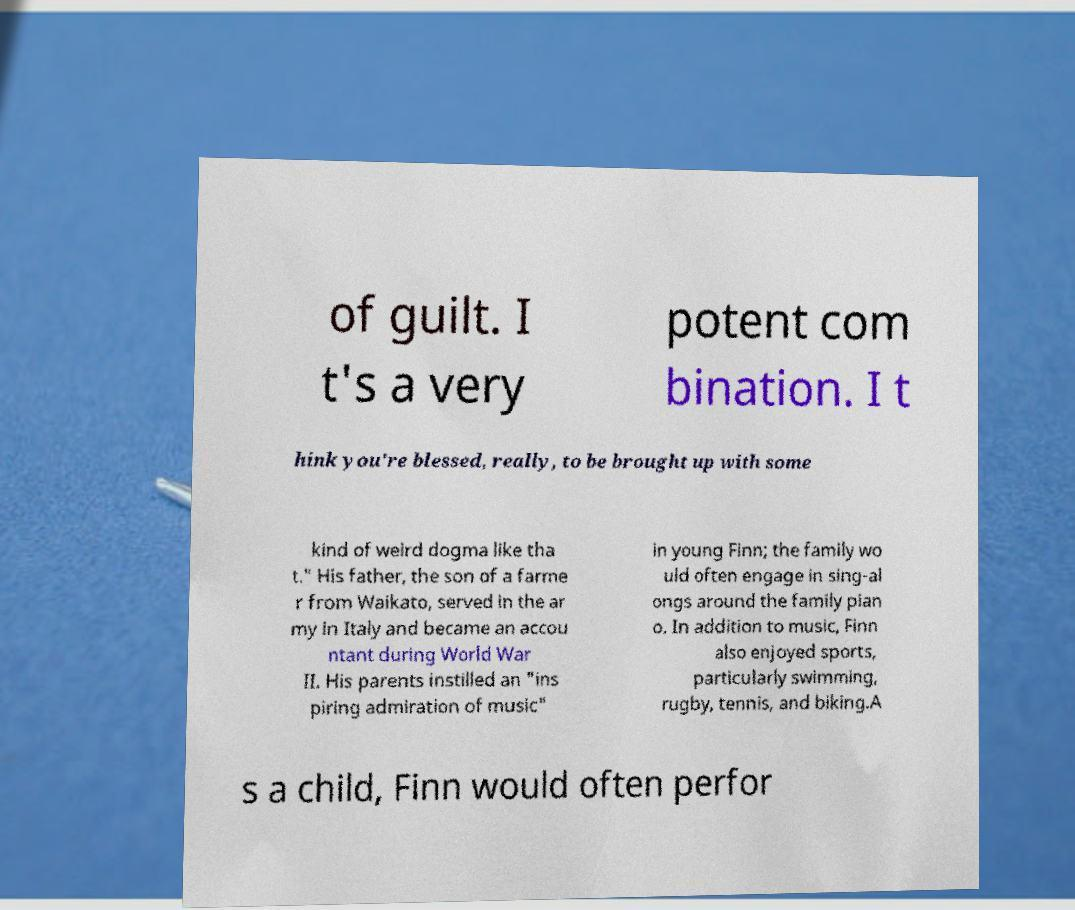Please identify and transcribe the text found in this image. of guilt. I t's a very potent com bination. I t hink you're blessed, really, to be brought up with some kind of weird dogma like tha t." His father, the son of a farme r from Waikato, served in the ar my in Italy and became an accou ntant during World War II. His parents instilled an "ins piring admiration of music" in young Finn; the family wo uld often engage in sing-al ongs around the family pian o. In addition to music, Finn also enjoyed sports, particularly swimming, rugby, tennis, and biking.A s a child, Finn would often perfor 